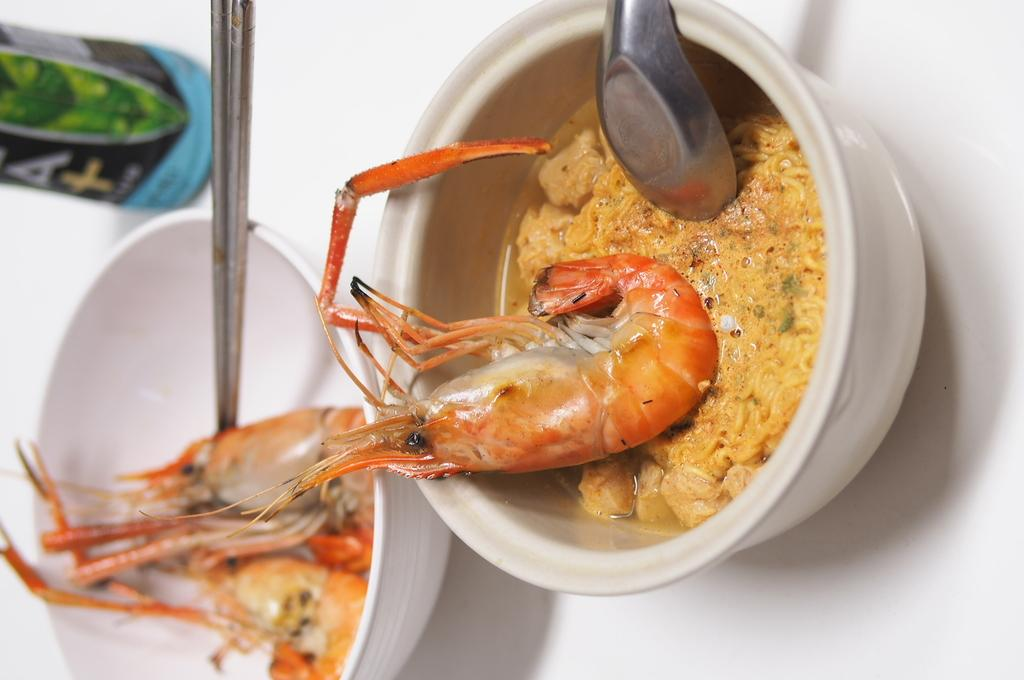How many bowls of food can be seen in the image? There are two bowls of food in the image. What utensils are provided with the bowls of food? Spoons are present with the bowls of food. Can you describe the location of the bottle in the image? The bottle is located towards the top left of the image. What type of feather can be seen in the image? There is no feather present in the image. What type of pleasure can be experienced by the food in the image? The food in the image is not capable of experiencing pleasure. 